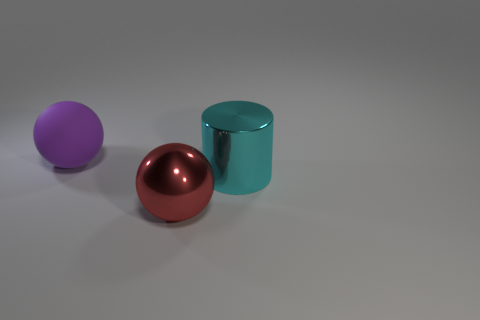Add 1 big cyan metallic objects. How many objects exist? 4 Subtract all cylinders. How many objects are left? 2 Subtract all purple metal objects. Subtract all big cyan metal objects. How many objects are left? 2 Add 3 red balls. How many red balls are left? 4 Add 3 tiny gray matte cylinders. How many tiny gray matte cylinders exist? 3 Subtract 0 green cubes. How many objects are left? 3 